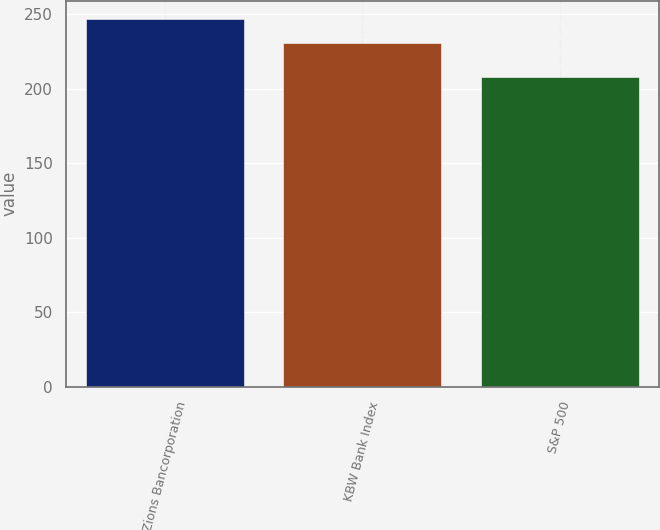Convert chart to OTSL. <chart><loc_0><loc_0><loc_500><loc_500><bar_chart><fcel>Zions Bancorporation<fcel>KBW Bank Index<fcel>S&P 500<nl><fcel>246.6<fcel>230.7<fcel>208.1<nl></chart> 